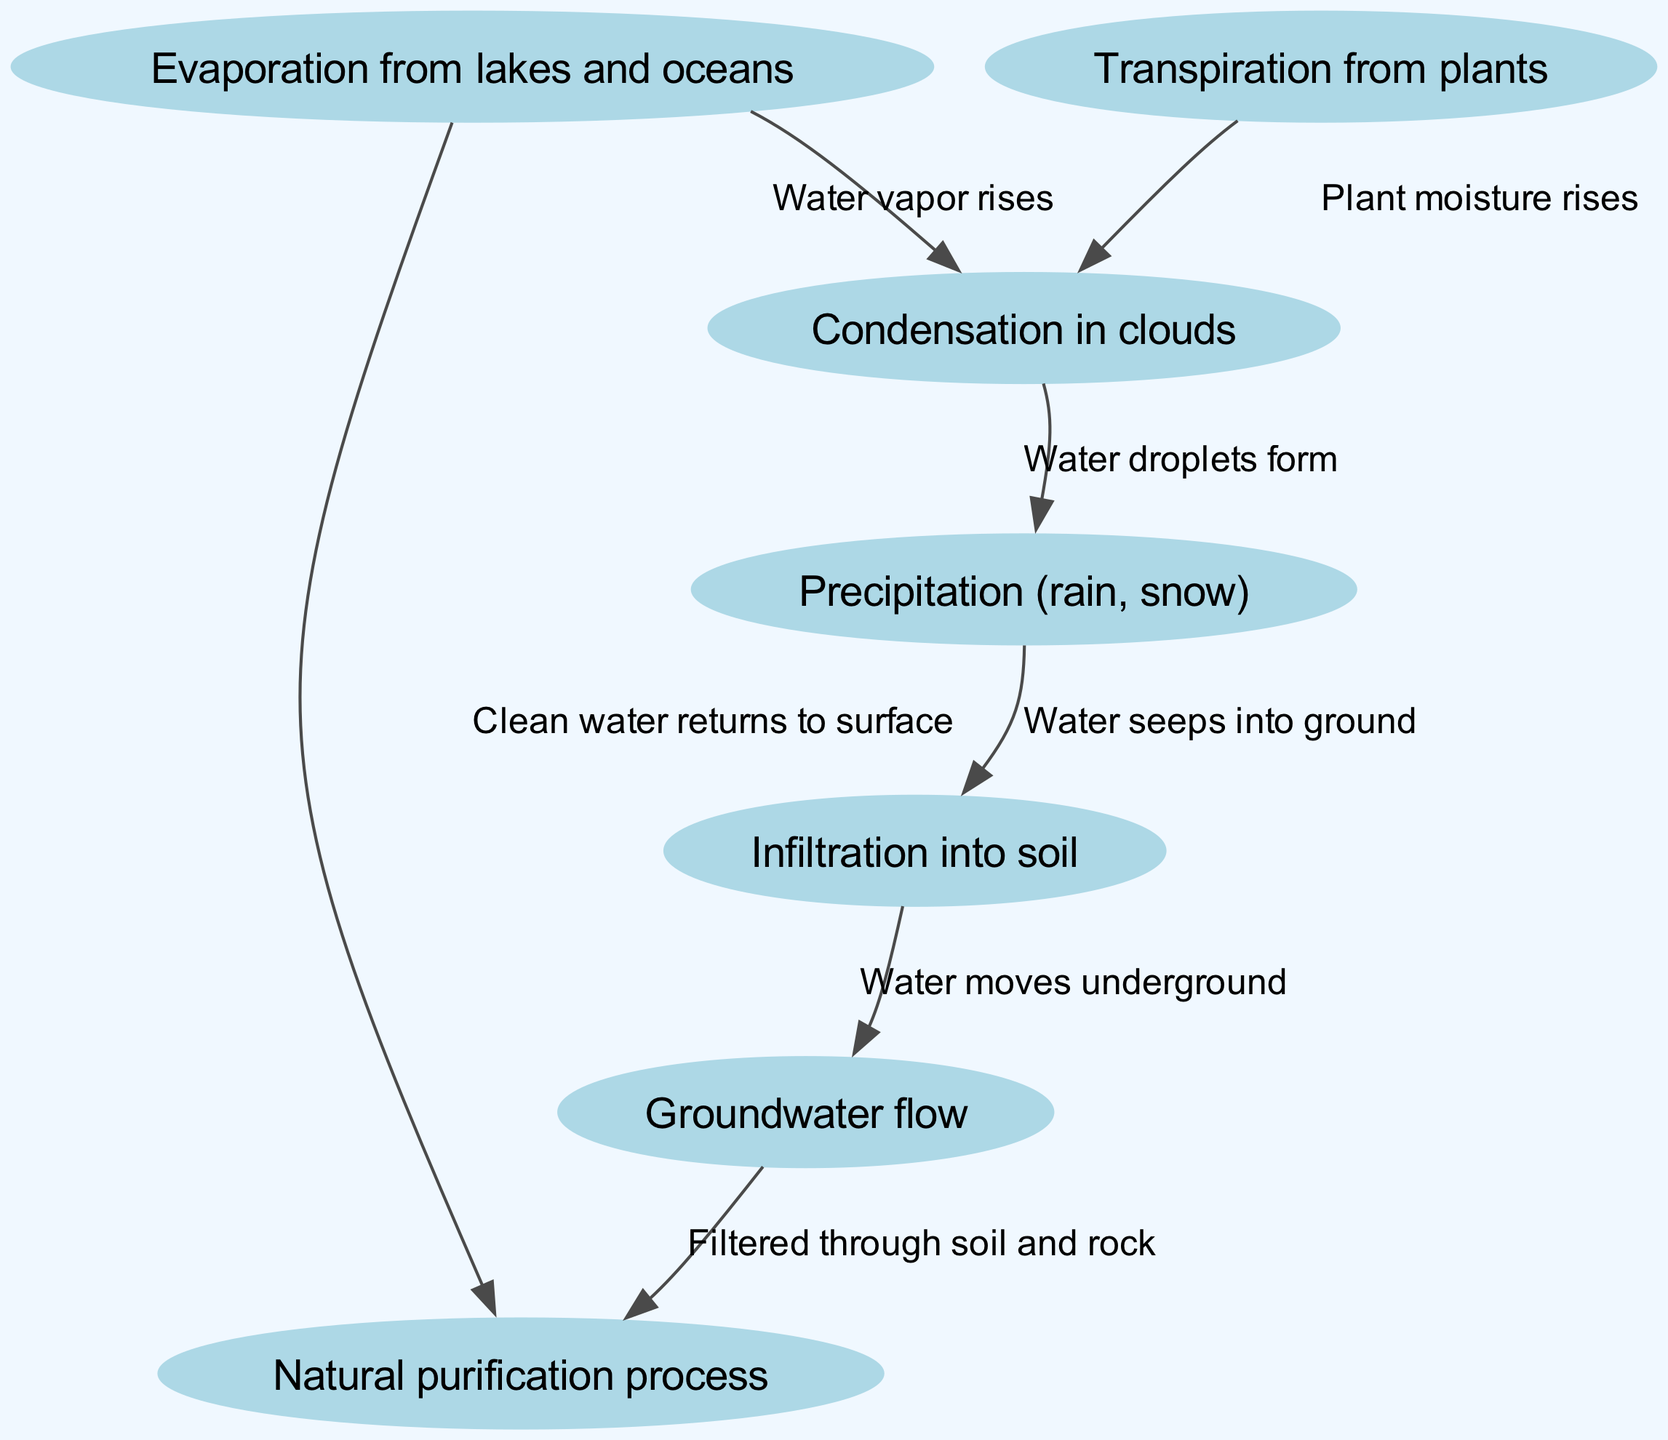What is the first step in the water cycle? The diagram shows "Evaporation from lakes and oceans" as the first node; this initiates the water cycle process.
Answer: Evaporation from lakes and oceans How many nodes are present in the diagram? Counting the unique nodes listed in the data, there are seven nodes: evaporation, transpiration, condensation, precipitation, infiltration, groundwater, and purification.
Answer: Seven What is the process that occurs after condensation? After condensation, the next event depicted is "Precipitation (rain, snow)," where water returns to the ground in various forms.
Answer: Precipitation (rain, snow) Which two processes are linked to condensation? The diagram connects both "Evaporation from lakes and oceans" and "Transpiration from plants" to the "Condensation in clouds," signifying that both contribute moisture to the air.
Answer: Evaporation and Transpiration What happens to water after infiltration? The water that infiltrates into the ground is shown to move into "Groundwater flow," indicating it travels underground after being absorbed.
Answer: Groundwater flow What is the final outcome of the purification process? The diagram indicates that after passing through the "Natural purification process," the clean water returns to "Evaporation from lakes and oceans," completing the cycle.
Answer: Clean water returns to surface Name the process that filters water through soil and rock. The arrow flowing from "Groundwater flow" to "Natural purification process" specifies that it is the "Filtered through soil and rock" that describes this filtering process.
Answer: Filtered through soil and rock Which step involves plant moisture contributing to the water cycle? The diagram illustrates "Transpiration from plants" as a key contributor to the water cycle, specifically influencing "Condensation in clouds."
Answer: Transpiration from plants How is natural purification achieved in the diagram? The diagram shows that natural purification occurs when water moves through "Groundwater flow" and is filtered, indicating a purification process takes place below ground before returning to the surface.
Answer: Filtered through soil and rock 